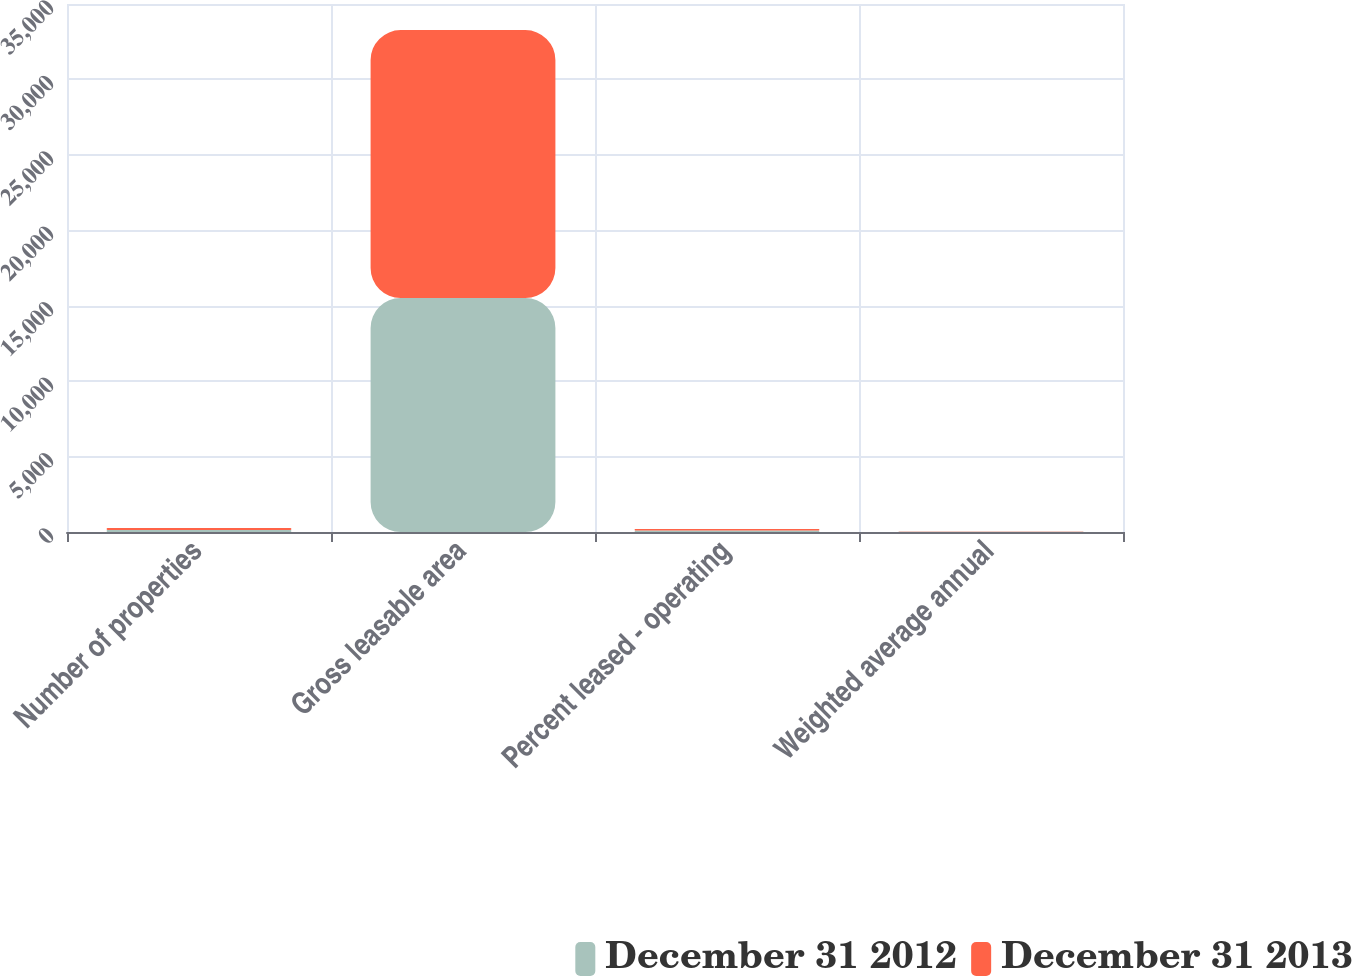Convert chart. <chart><loc_0><loc_0><loc_500><loc_500><stacked_bar_chart><ecel><fcel>Number of properties<fcel>Gross leasable area<fcel>Percent leased - operating<fcel>Weighted average annual<nl><fcel>December 31 2012<fcel>126<fcel>15508<fcel>96.2<fcel>17.34<nl><fcel>December 31 2013<fcel>144<fcel>17762<fcel>95.2<fcel>17.03<nl></chart> 